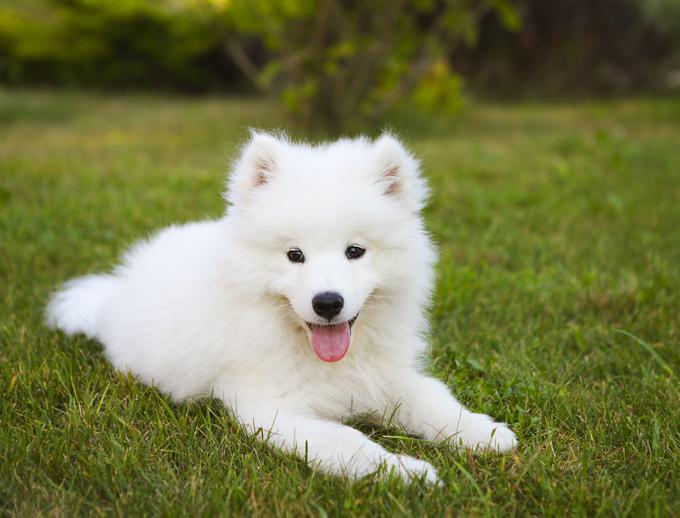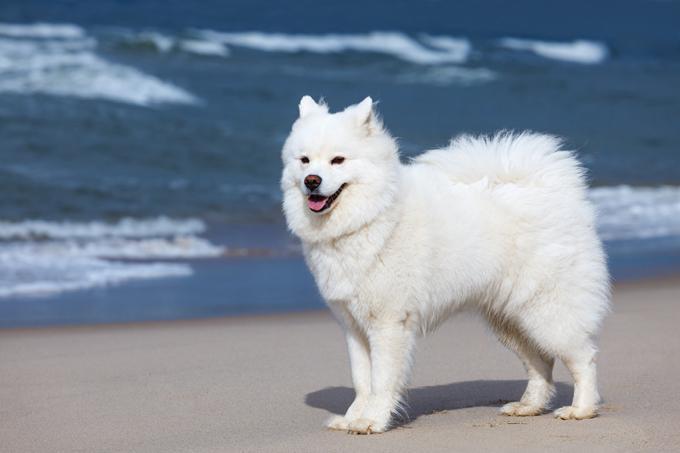The first image is the image on the left, the second image is the image on the right. Given the left and right images, does the statement "There is exactly on dog in the image on the right." hold true? Answer yes or no. Yes. 